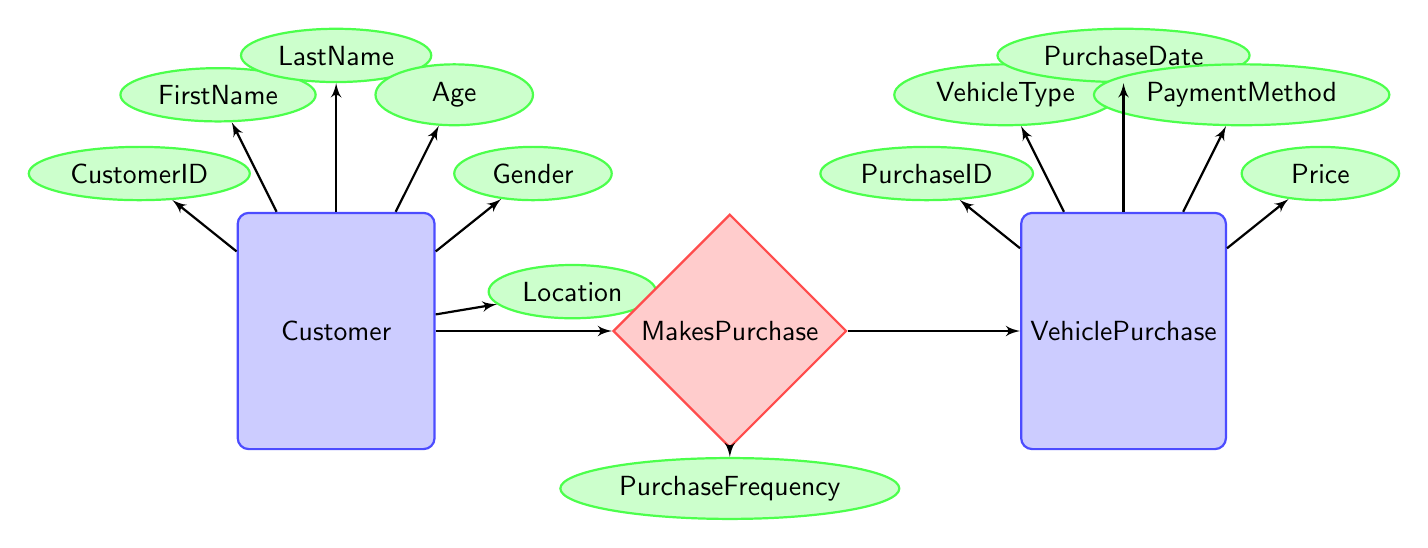What is the primary entity represented in the diagram? The diagram includes two primary entities: Customer and VehiclePurchase. The question focuses on identifying which one is primary; the customer is generally recognized as the main focus in this context.
Answer: Customer How many attributes does the Customer entity have? By reviewing the Customer entity, a total of six attributes are listed: CustomerID, FirstName, LastName, Age, Gender, and Location. Therefore, the answer is derived from counting these attributes.
Answer: 6 What relationship is defined between Customer and VehiclePurchase? The relationship specified in the diagram is called MakesPurchase, indicating that there is an association between customers and their vehicle purchases. This relationship is explicitly labeled in the diagram.
Answer: MakesPurchase What attribute is associated with the MakesPurchase relationship? The MakesPurchase relationship has one associated attribute, which is PurchaseFrequency, detailing how often a customer makes a purchase. This attribute is connected directly to the relationship node in the diagram.
Answer: PurchaseFrequency What are the included attributes of the VehiclePurchase entity? The VehiclePurchase entity has five specified attributes: PurchaseID, VehicleType, PurchaseDate, PaymentMethod, and Price. This is determined by listing the attributes attached to the VehiclePurchase entity in the diagram.
Answer: PurchaseID, VehicleType, PurchaseDate, PaymentMethod, Price How many entities are illustrated in the diagram? The diagram illustrates two main entities, which are Customer and VehiclePurchase, as confirmed by counting the entities located in the diagram.
Answer: 2 What attribute describes a customer's location? The attribute that describes a customer's location is simply labeled Location, as specified within the Customer entity in the diagram.
Answer: Location Which entity possesses the attribute PaymentMethod? The PaymentMethod attribute is part of the VehiclePurchase entity, which organizes various details regarding the purchase, including how payment is made. This is directly indicated under the VehiclePurchase entity.
Answer: VehiclePurchase Which entity represents demographic information? The Customer entity is primarily associated with demographic information such as age, gender, and location, demonstrating the focus on customer characteristics in the diagram.
Answer: Customer 